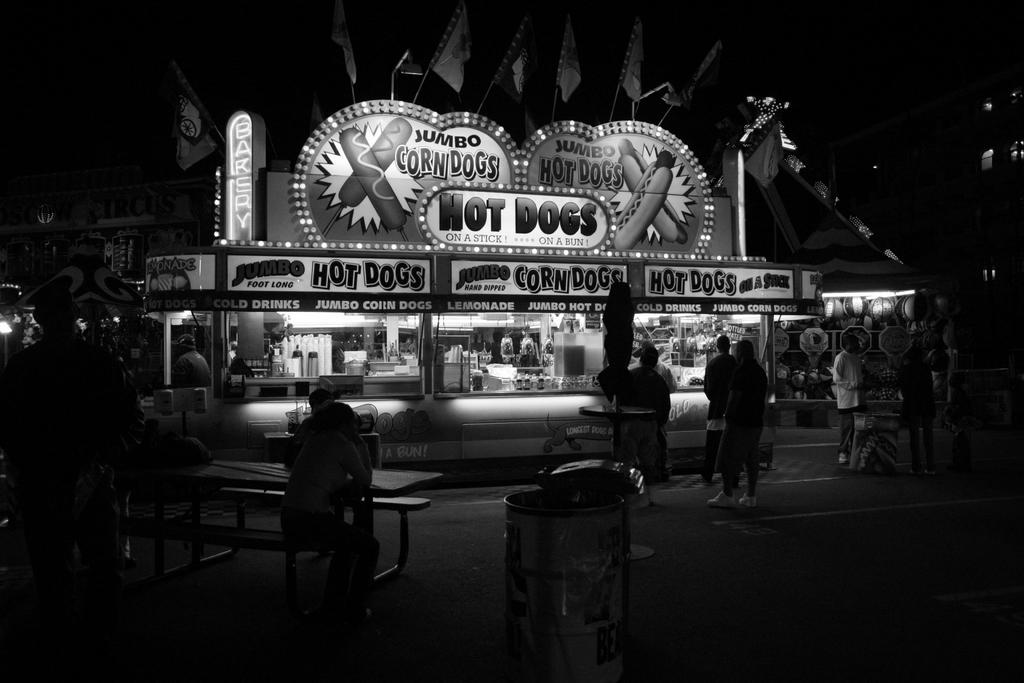<image>
Relay a brief, clear account of the picture shown. A hot dog stand at a carnival has very few people in line. 